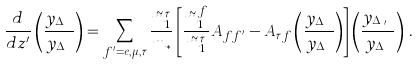<formula> <loc_0><loc_0><loc_500><loc_500>\frac { d } { d z ^ { \prime } } \left ( \frac { y _ { \Delta _ { f } } } { y _ { \Delta _ { \tau } } } \right ) = \sum _ { f ^ { \prime } = e , \mu , \tau } \frac { \tilde { m } _ { 1 } ^ { \tau } } { m _ { * } } \left [ \frac { \tilde { m } _ { 1 } ^ { f } } { \tilde { m } _ { 1 } ^ { \tau } } A _ { f f ^ { \prime } } - A _ { \tau f } \left ( \frac { y _ { \Delta _ { f } } } { y _ { \Delta _ { \tau } } } \right ) \right ] \left ( \frac { y _ { \Delta _ { f ^ { \prime } } } } { y _ { \Delta _ { \tau } } } \right ) \, .</formula> 